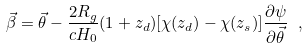<formula> <loc_0><loc_0><loc_500><loc_500>\vec { \beta } = \vec { \theta } - \frac { 2 R _ { g } } { c H _ { 0 } } ( 1 + z _ { d } ) [ \chi ( z _ { d } ) - \chi ( z _ { s } ) ] \frac { \partial { \psi } } { \partial { \vec { \theta } } } \ ,</formula> 